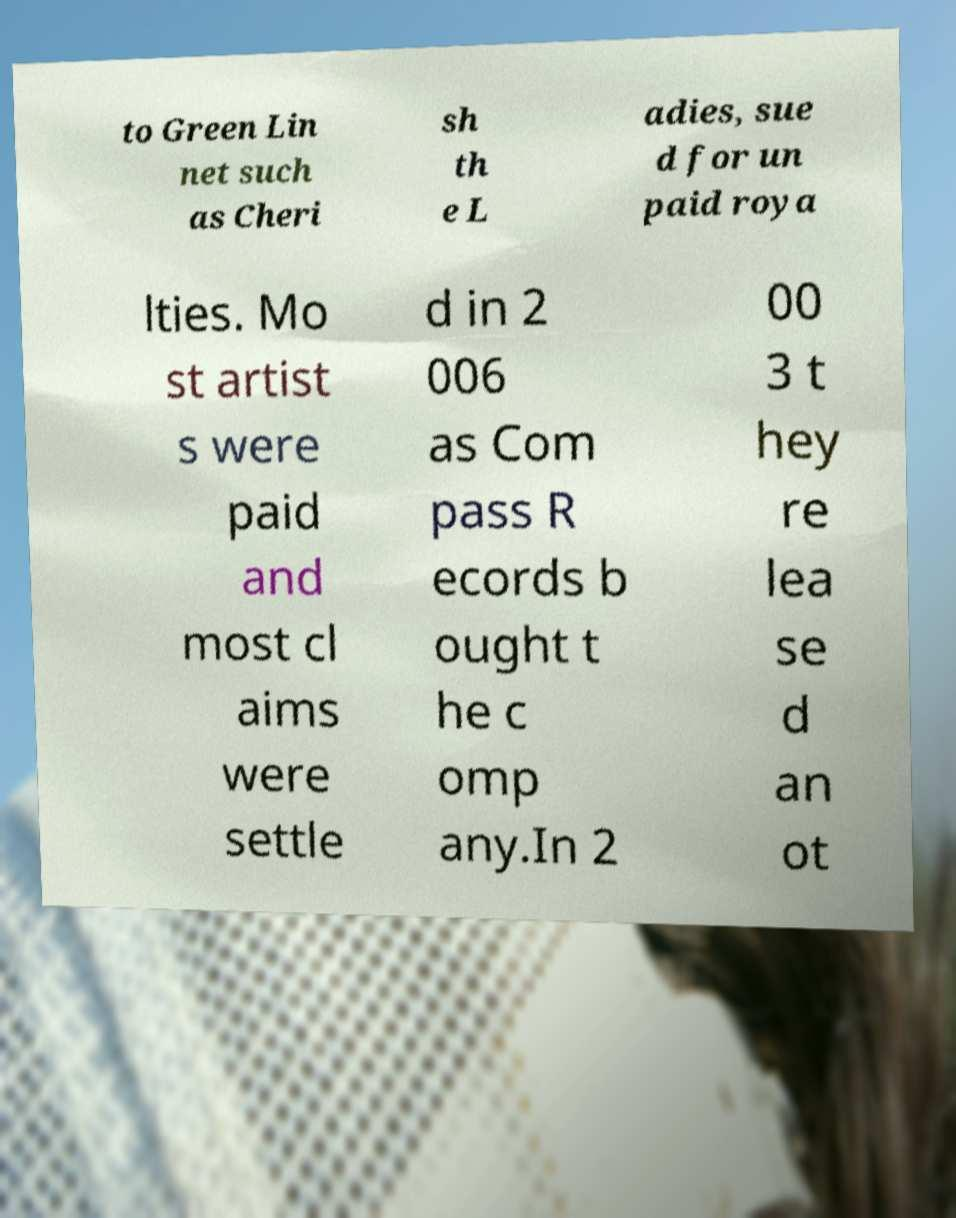Can you read and provide the text displayed in the image?This photo seems to have some interesting text. Can you extract and type it out for me? to Green Lin net such as Cheri sh th e L adies, sue d for un paid roya lties. Mo st artist s were paid and most cl aims were settle d in 2 006 as Com pass R ecords b ought t he c omp any.In 2 00 3 t hey re lea se d an ot 